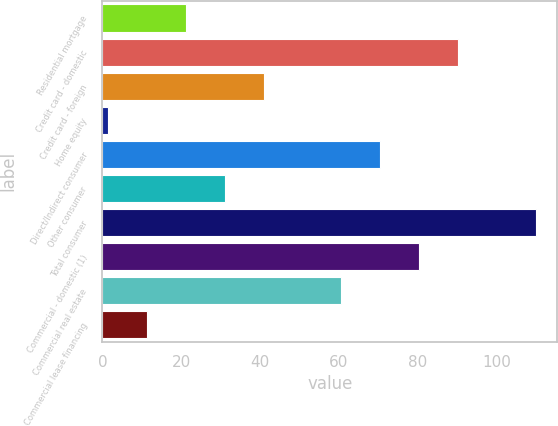<chart> <loc_0><loc_0><loc_500><loc_500><bar_chart><fcel>Residential mortgage<fcel>Credit card - domestic<fcel>Credit card - foreign<fcel>Home equity<fcel>Direct/Indirect consumer<fcel>Other consumer<fcel>Total consumer<fcel>Commercial - domestic (1)<fcel>Commercial real estate<fcel>Commercial lease financing<nl><fcel>21.2<fcel>90.15<fcel>40.9<fcel>1.5<fcel>70.45<fcel>31.05<fcel>109.85<fcel>80.3<fcel>60.6<fcel>11.35<nl></chart> 